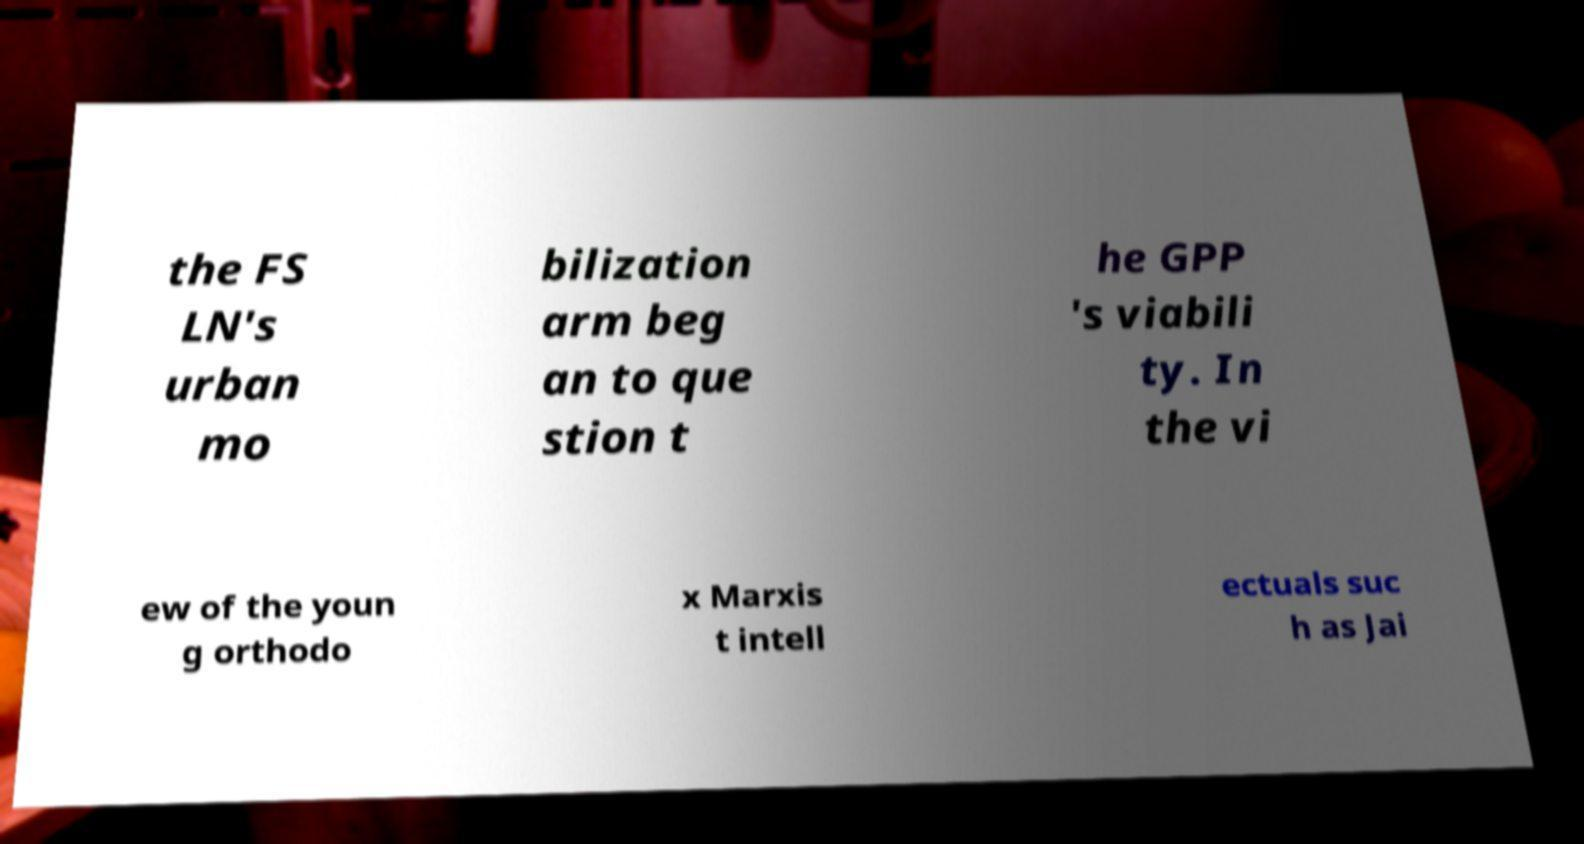For documentation purposes, I need the text within this image transcribed. Could you provide that? the FS LN's urban mo bilization arm beg an to que stion t he GPP 's viabili ty. In the vi ew of the youn g orthodo x Marxis t intell ectuals suc h as Jai 